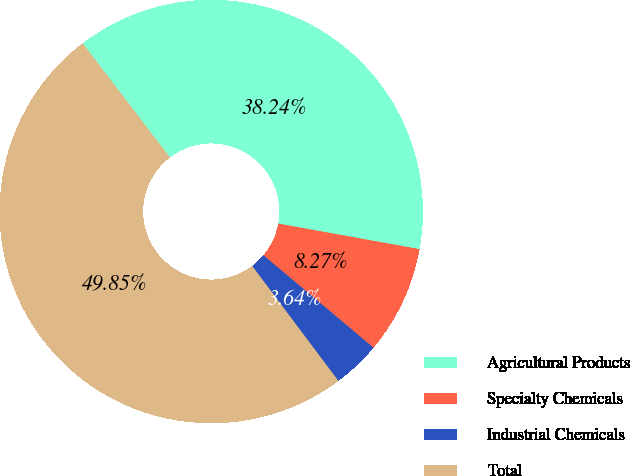Convert chart to OTSL. <chart><loc_0><loc_0><loc_500><loc_500><pie_chart><fcel>Agricultural Products<fcel>Specialty Chemicals<fcel>Industrial Chemicals<fcel>Total<nl><fcel>38.24%<fcel>8.27%<fcel>3.64%<fcel>49.85%<nl></chart> 